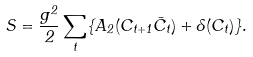<formula> <loc_0><loc_0><loc_500><loc_500>S = \frac { g ^ { 2 } } { 2 } \sum _ { t } \{ A _ { 2 } ( C _ { t + 1 } \bar { C } _ { t } ) + \Lambda ( C _ { t } ) \} .</formula> 